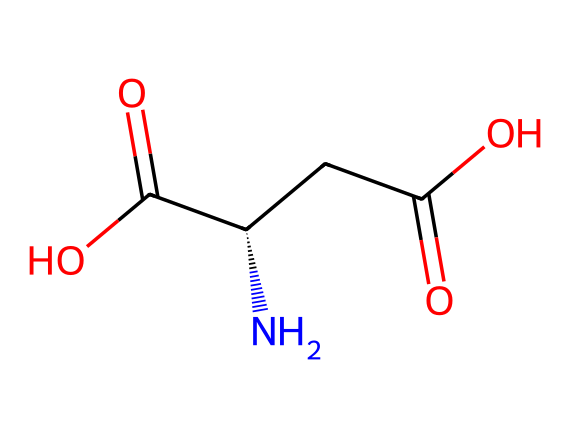What is the name of this amino acid? The SMILES representation includes “N” indicating an amino group, and “C(=O)O” showing the presence of carboxylic acids, which identifies it as an amino acid. Looking for common amino acids with this structure, the name corresponds to glutamic acid.
Answer: glutamic acid How many carbon atoms are in this molecule? The SMILES representation shows “C(C(=O)O)” and “C(=O)O,” where each “C” represents a carbon atom. Counting these, we find there are three carbon atoms in total.
Answer: three What type of functional groups are present in this amino acid? The structure includes an amino group (-NH2) indicated by "N" and two carboxylic acid groups (-COOH) shown by “C(=O)O.” Therefore, these identify the functional groups.
Answer: amino and carboxylic acid Is this amino acid acidic or basic? The presence of multiple carboxylic acid groups in the structure indicates that this amino acid donates protons, hence it is considered acidic.
Answer: acidic What is the pKa of the carboxylic groups present? Amino acids typically have pKa values for their carboxylic groups around 2 to 4. For glutamic acid specifically, the pKa of its carboxyl groups is approximately 2.1 and 4.2.
Answer: around 4.2 How many nitrogen atoms are in this molecule? The structure only contains one nitrogen atom, indicated by the “N” present in the SMILES representation.
Answer: one Does this amino acid contribute to bird nutrition during migration? Essential amino acids, like glutamic acid, provide important nutrients for energy and physiological functions in migrating birds. The presence of these nutrients assists in metabolism and energy balance.
Answer: yes 